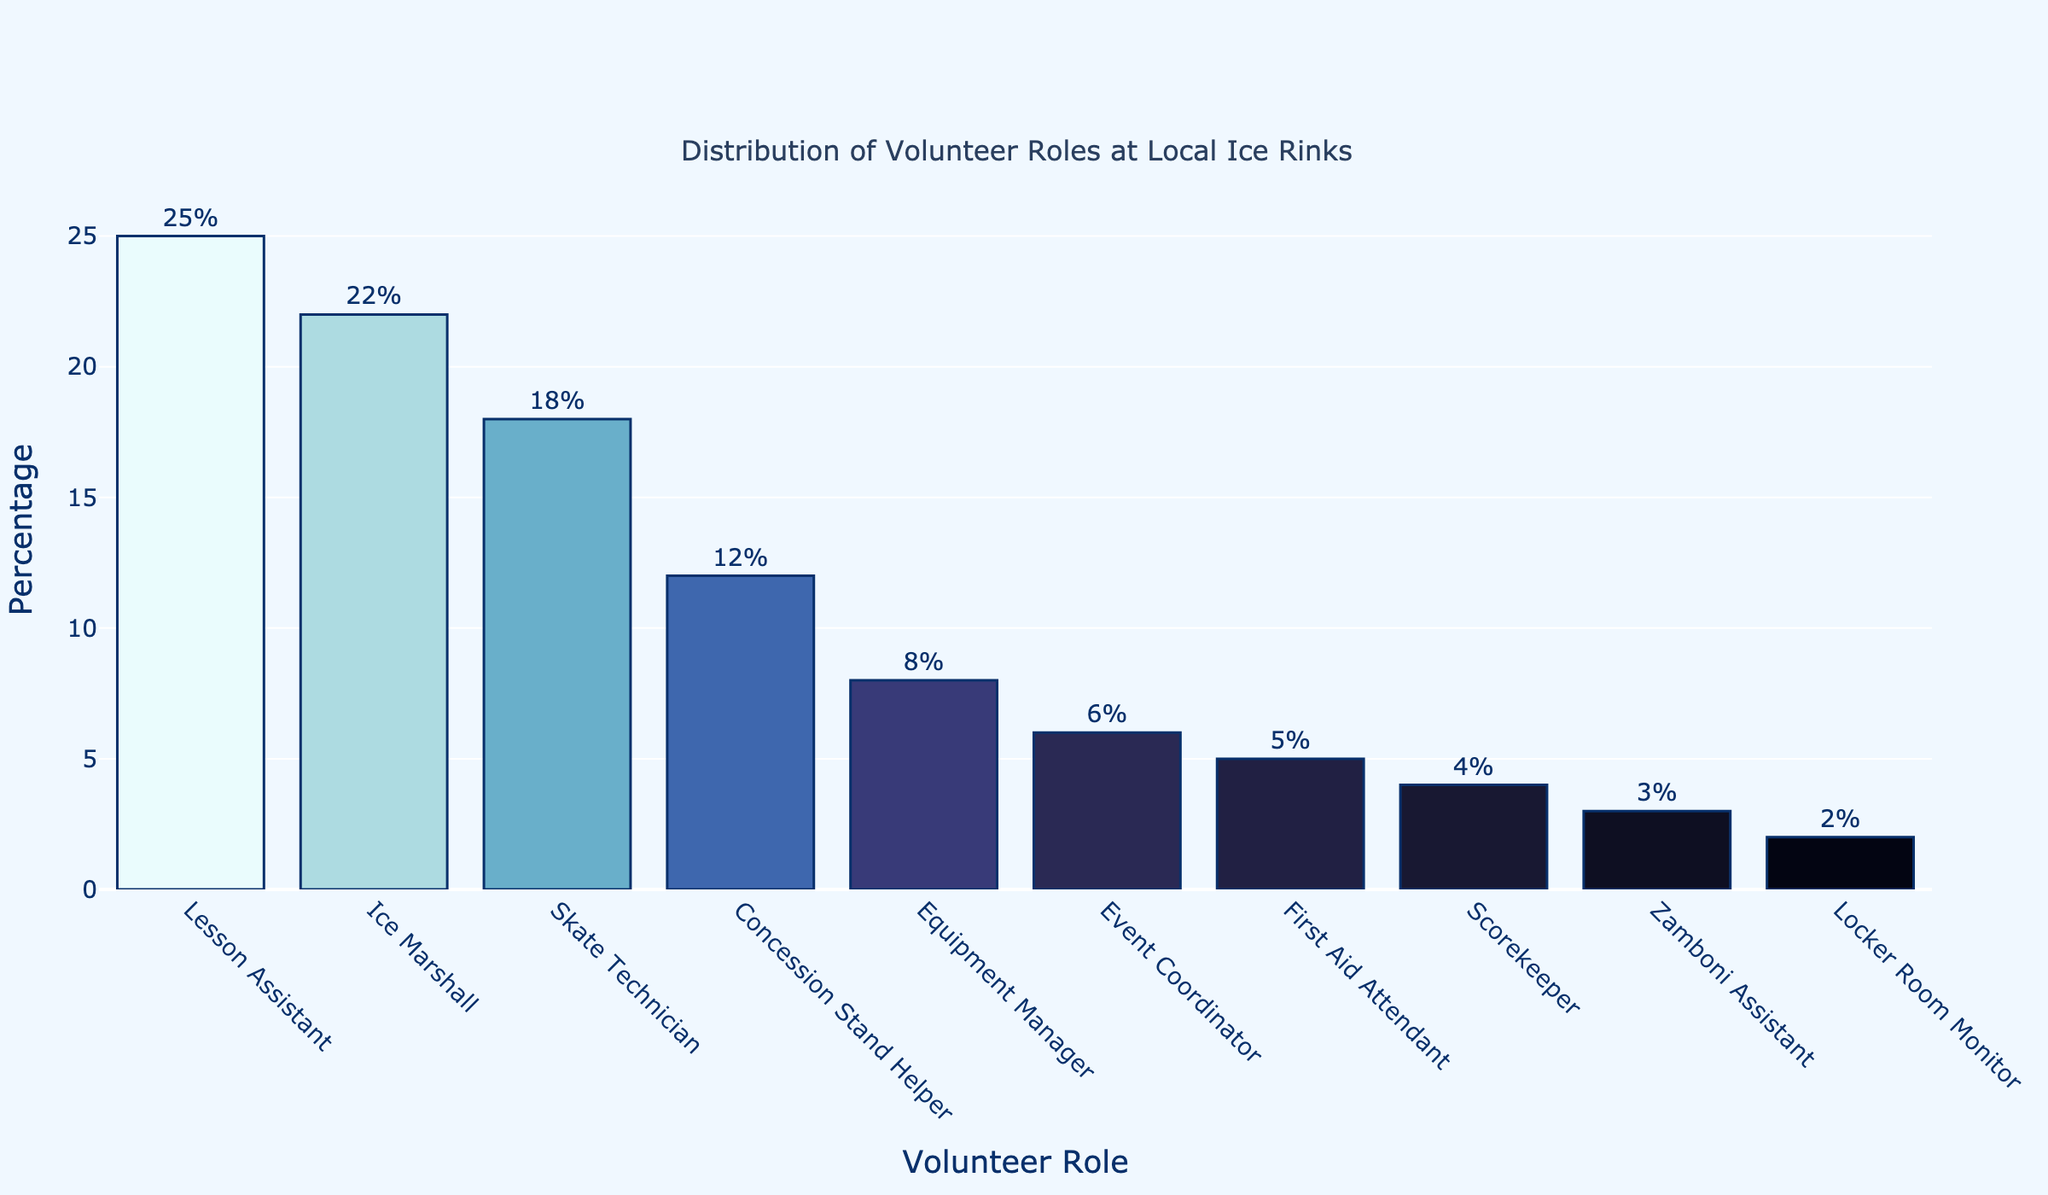What volunteer role has the highest percentage? By inspecting the bar chart, we see which bar reaches the highest point on the y-axis indicating the highest percentage.
Answer: Lesson Assistant What volunteer role has the lowest percentage? By inspecting the bar chart, we can see which bar just barely rises from the x-axis indicating the lowest percentage.
Answer: Locker Room Monitor How many volunteer roles have percentages greater than 10%? Identify and count all bars whose heights represent percentages greater than 10%.
Answer: Four Compare the percentage of Skate Technician to Event Coordinator. Examine the heights of the bars representing Skate Technician and Event Coordinator, noting that Skate Technician's bar is significantly higher.
Answer: Skate Technician has a higher percentage What is the combined percentage of First Aid Attendant and Scorekeeper roles? Add the percentages of First Aid Attendant (5%) and Scorekeeper (4%).
Answer: 9% Which volunteer role is just above 20% in the distribution? Find the bar whose height closely exceeds the 20% mark on the y-axis.
Answer: Ice Marshall What role falls exactly in the middle when sorted by percentage in descending order? Considering the sorted list given in the code, identify the middle value.
Answer: Equipment Manager How much more popular is the Lesson Assistant than the Concession Stand Helper? Subtract the percentage of Concession Stand Helper (12%) from the percentage of Lesson Assistant (25%).
Answer: 13% What roles have a combined percentage of 35%? Find a combination of roles whose percentages sum to 35%, such as Ice Marshall (22%) and Skate Technician (18%) noting they sum to 40%. Hence, try another combination.
Answer: Skate Technician and Concession Stand Helper Which volunteer roles have percentages that are divisible by 3? Identify the roles whose percentages (when divided by 3) leave no remainder. Check them off accordingly: Ice Marshall (22%%3==1), Event Coordinator (6%3==0), Scorekeeper (4%3==1), Zamboni Assistant (3%3==0).
Answer: Event Coordinator and Zamboni Assistant 